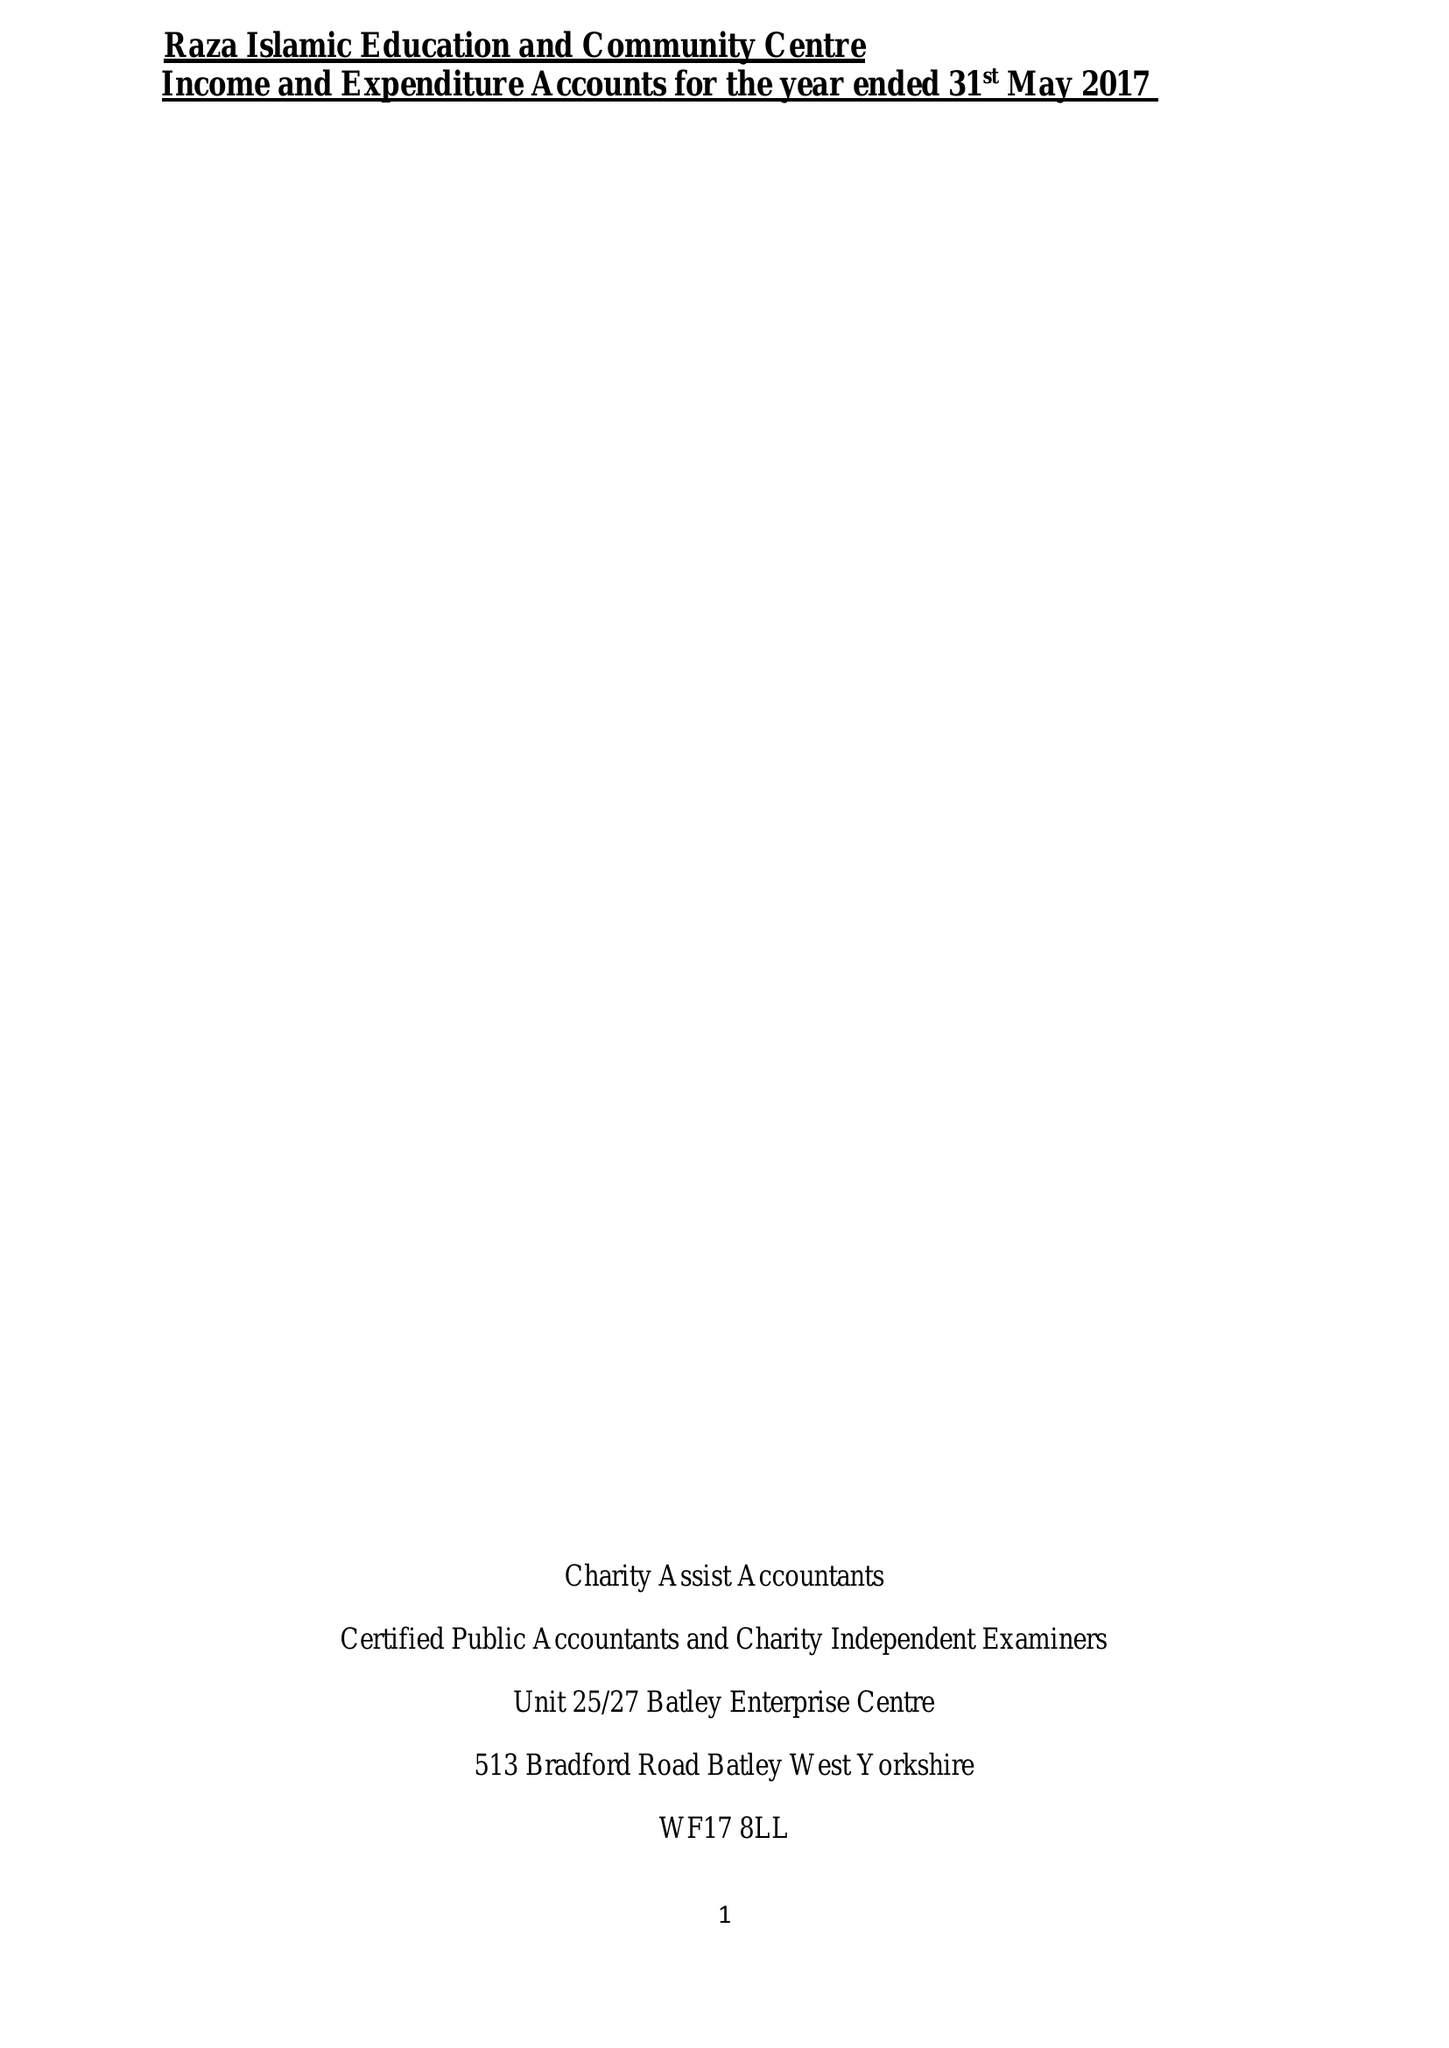What is the value for the address__street_line?
Answer the question using a single word or phrase. 399 LEES HALL ROAD 